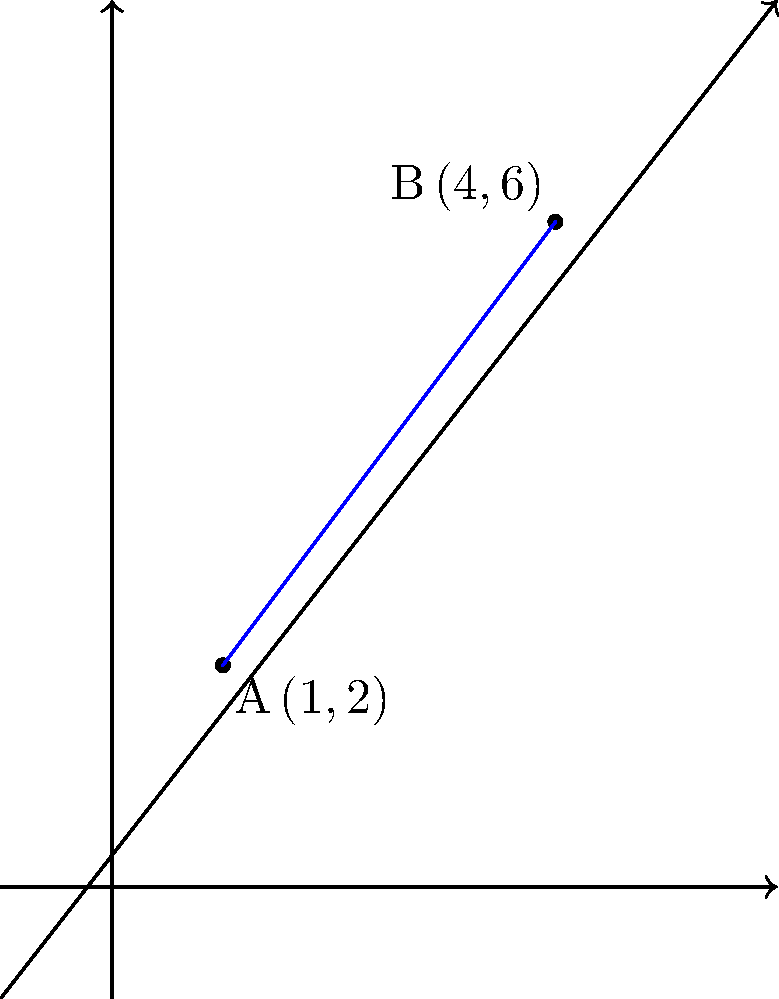As competitors in the business world, we often analyze market trends using data visualization techniques. Consider the graph above, which represents two key performance indicators for our respective businesses over time. The points A(1,2) and B(4,6) represent our companies' positions in the market at two different time periods. Calculate the slope of the line passing through these two points to determine the rate of change in our market positions. To find the slope of the line passing through two points, we use the slope formula:

$$ m = \frac{y_2 - y_1}{x_2 - x_1} $$

Where $(x_1, y_1)$ is the first point and $(x_2, y_2)$ is the second point.

Given:
Point A: $(x_1, y_1) = (1, 2)$
Point B: $(x_2, y_2) = (4, 6)$

Let's plug these values into the formula:

$$ m = \frac{6 - 2}{4 - 1} = \frac{4}{3} $$

Simplifying:

$$ m = \frac{4}{3} \approx 1.33 $$

This slope indicates that for every 1 unit increase in the x-direction, there is a $\frac{4}{3}$ unit increase in the y-direction, representing the rate of change between our market positions over time.
Answer: $\frac{4}{3}$ 